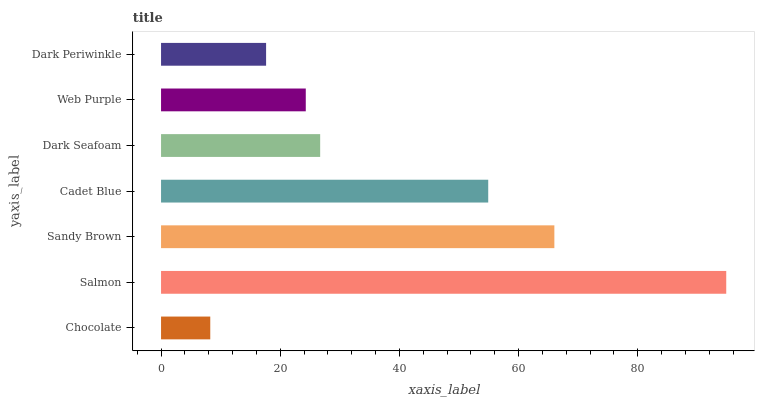Is Chocolate the minimum?
Answer yes or no. Yes. Is Salmon the maximum?
Answer yes or no. Yes. Is Sandy Brown the minimum?
Answer yes or no. No. Is Sandy Brown the maximum?
Answer yes or no. No. Is Salmon greater than Sandy Brown?
Answer yes or no. Yes. Is Sandy Brown less than Salmon?
Answer yes or no. Yes. Is Sandy Brown greater than Salmon?
Answer yes or no. No. Is Salmon less than Sandy Brown?
Answer yes or no. No. Is Dark Seafoam the high median?
Answer yes or no. Yes. Is Dark Seafoam the low median?
Answer yes or no. Yes. Is Chocolate the high median?
Answer yes or no. No. Is Web Purple the low median?
Answer yes or no. No. 